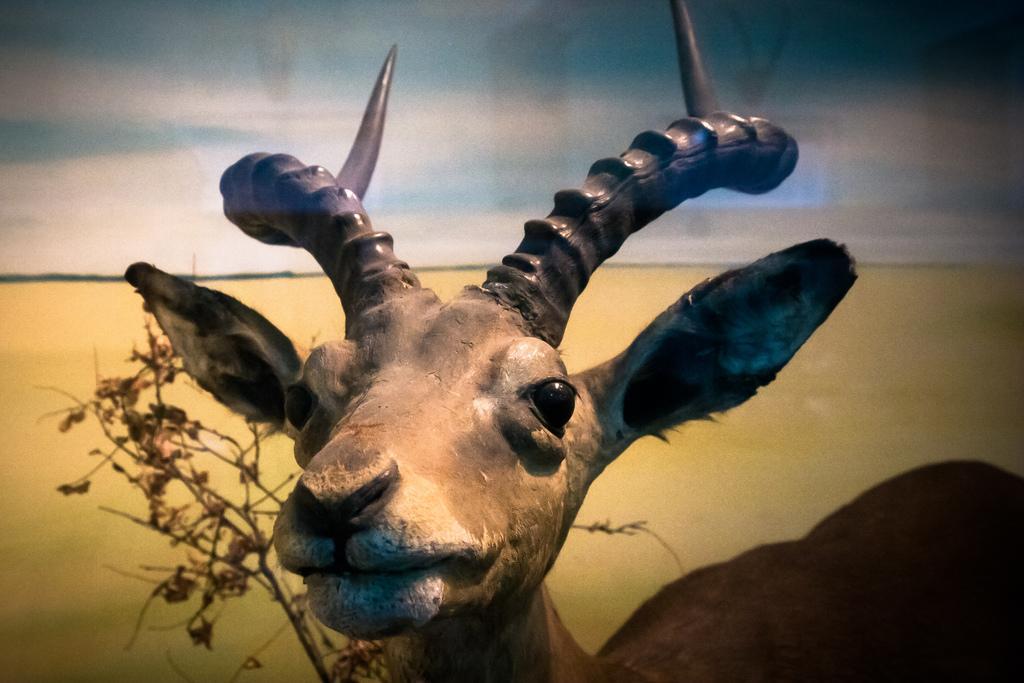In one or two sentences, can you explain what this image depicts? In the picture we can see a deer and beside we can see a dried plant and in the background we can see a sand surface. 